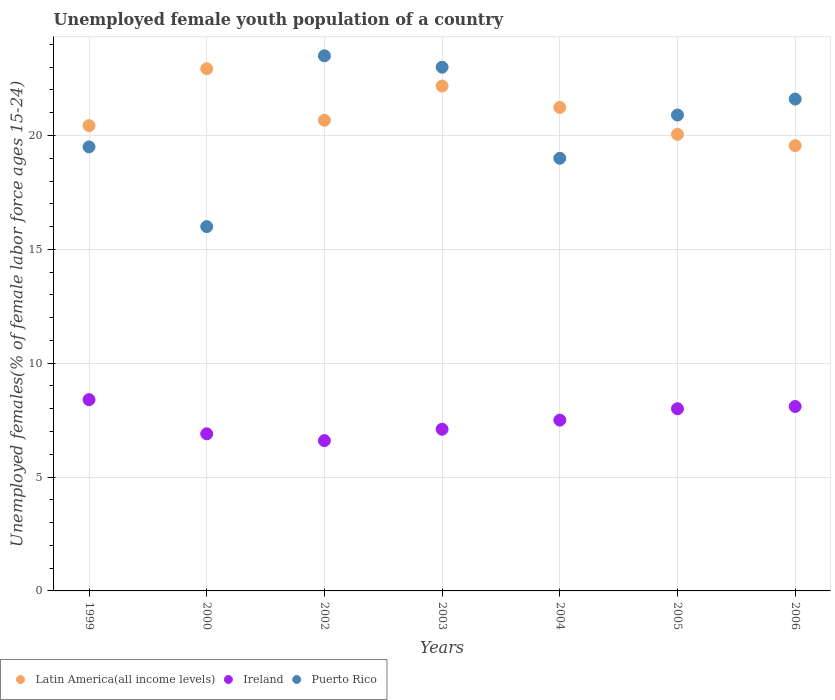What is the percentage of unemployed female youth population in Ireland in 2006?
Your answer should be very brief. 8.1. Across all years, what is the maximum percentage of unemployed female youth population in Puerto Rico?
Keep it short and to the point. 23.5. Across all years, what is the minimum percentage of unemployed female youth population in Puerto Rico?
Offer a terse response. 16. In which year was the percentage of unemployed female youth population in Puerto Rico minimum?
Keep it short and to the point. 2000. What is the total percentage of unemployed female youth population in Latin America(all income levels) in the graph?
Your answer should be very brief. 147.05. What is the difference between the percentage of unemployed female youth population in Ireland in 2002 and that in 2006?
Give a very brief answer. -1.5. What is the difference between the percentage of unemployed female youth population in Puerto Rico in 2002 and the percentage of unemployed female youth population in Latin America(all income levels) in 2005?
Make the answer very short. 3.45. What is the average percentage of unemployed female youth population in Latin America(all income levels) per year?
Offer a very short reply. 21.01. In the year 2005, what is the difference between the percentage of unemployed female youth population in Latin America(all income levels) and percentage of unemployed female youth population in Puerto Rico?
Keep it short and to the point. -0.85. In how many years, is the percentage of unemployed female youth population in Puerto Rico greater than 6 %?
Your response must be concise. 7. What is the ratio of the percentage of unemployed female youth population in Latin America(all income levels) in 2004 to that in 2005?
Make the answer very short. 1.06. What is the difference between the highest and the second highest percentage of unemployed female youth population in Latin America(all income levels)?
Provide a short and direct response. 0.76. What is the difference between the highest and the lowest percentage of unemployed female youth population in Latin America(all income levels)?
Your response must be concise. 3.38. Is the sum of the percentage of unemployed female youth population in Latin America(all income levels) in 2000 and 2004 greater than the maximum percentage of unemployed female youth population in Puerto Rico across all years?
Give a very brief answer. Yes. Is it the case that in every year, the sum of the percentage of unemployed female youth population in Latin America(all income levels) and percentage of unemployed female youth population in Ireland  is greater than the percentage of unemployed female youth population in Puerto Rico?
Provide a short and direct response. Yes. How many dotlines are there?
Your answer should be very brief. 3. What is the difference between two consecutive major ticks on the Y-axis?
Make the answer very short. 5. Does the graph contain any zero values?
Your response must be concise. No. Does the graph contain grids?
Your answer should be very brief. Yes. How many legend labels are there?
Your answer should be very brief. 3. What is the title of the graph?
Your answer should be compact. Unemployed female youth population of a country. Does "Burundi" appear as one of the legend labels in the graph?
Give a very brief answer. No. What is the label or title of the Y-axis?
Your answer should be compact. Unemployed females(% of female labor force ages 15-24). What is the Unemployed females(% of female labor force ages 15-24) in Latin America(all income levels) in 1999?
Provide a succinct answer. 20.43. What is the Unemployed females(% of female labor force ages 15-24) of Ireland in 1999?
Offer a very short reply. 8.4. What is the Unemployed females(% of female labor force ages 15-24) in Latin America(all income levels) in 2000?
Offer a very short reply. 22.93. What is the Unemployed females(% of female labor force ages 15-24) in Ireland in 2000?
Keep it short and to the point. 6.9. What is the Unemployed females(% of female labor force ages 15-24) of Puerto Rico in 2000?
Offer a terse response. 16. What is the Unemployed females(% of female labor force ages 15-24) of Latin America(all income levels) in 2002?
Provide a succinct answer. 20.67. What is the Unemployed females(% of female labor force ages 15-24) in Ireland in 2002?
Your response must be concise. 6.6. What is the Unemployed females(% of female labor force ages 15-24) in Latin America(all income levels) in 2003?
Give a very brief answer. 22.17. What is the Unemployed females(% of female labor force ages 15-24) in Ireland in 2003?
Offer a very short reply. 7.1. What is the Unemployed females(% of female labor force ages 15-24) of Latin America(all income levels) in 2004?
Your answer should be compact. 21.23. What is the Unemployed females(% of female labor force ages 15-24) in Latin America(all income levels) in 2005?
Ensure brevity in your answer.  20.05. What is the Unemployed females(% of female labor force ages 15-24) in Ireland in 2005?
Make the answer very short. 8. What is the Unemployed females(% of female labor force ages 15-24) in Puerto Rico in 2005?
Ensure brevity in your answer.  20.9. What is the Unemployed females(% of female labor force ages 15-24) in Latin America(all income levels) in 2006?
Make the answer very short. 19.56. What is the Unemployed females(% of female labor force ages 15-24) in Ireland in 2006?
Give a very brief answer. 8.1. What is the Unemployed females(% of female labor force ages 15-24) in Puerto Rico in 2006?
Offer a very short reply. 21.6. Across all years, what is the maximum Unemployed females(% of female labor force ages 15-24) in Latin America(all income levels)?
Offer a very short reply. 22.93. Across all years, what is the maximum Unemployed females(% of female labor force ages 15-24) of Ireland?
Offer a very short reply. 8.4. Across all years, what is the maximum Unemployed females(% of female labor force ages 15-24) of Puerto Rico?
Give a very brief answer. 23.5. Across all years, what is the minimum Unemployed females(% of female labor force ages 15-24) of Latin America(all income levels)?
Offer a very short reply. 19.56. Across all years, what is the minimum Unemployed females(% of female labor force ages 15-24) of Ireland?
Your response must be concise. 6.6. What is the total Unemployed females(% of female labor force ages 15-24) in Latin America(all income levels) in the graph?
Your answer should be compact. 147.05. What is the total Unemployed females(% of female labor force ages 15-24) in Ireland in the graph?
Ensure brevity in your answer.  52.6. What is the total Unemployed females(% of female labor force ages 15-24) of Puerto Rico in the graph?
Offer a very short reply. 143.5. What is the difference between the Unemployed females(% of female labor force ages 15-24) of Latin America(all income levels) in 1999 and that in 2000?
Offer a very short reply. -2.5. What is the difference between the Unemployed females(% of female labor force ages 15-24) in Latin America(all income levels) in 1999 and that in 2002?
Your response must be concise. -0.24. What is the difference between the Unemployed females(% of female labor force ages 15-24) of Puerto Rico in 1999 and that in 2002?
Provide a short and direct response. -4. What is the difference between the Unemployed females(% of female labor force ages 15-24) in Latin America(all income levels) in 1999 and that in 2003?
Your response must be concise. -1.74. What is the difference between the Unemployed females(% of female labor force ages 15-24) of Latin America(all income levels) in 1999 and that in 2004?
Make the answer very short. -0.8. What is the difference between the Unemployed females(% of female labor force ages 15-24) of Latin America(all income levels) in 1999 and that in 2005?
Your answer should be very brief. 0.38. What is the difference between the Unemployed females(% of female labor force ages 15-24) of Latin America(all income levels) in 1999 and that in 2006?
Keep it short and to the point. 0.88. What is the difference between the Unemployed females(% of female labor force ages 15-24) of Ireland in 1999 and that in 2006?
Keep it short and to the point. 0.3. What is the difference between the Unemployed females(% of female labor force ages 15-24) of Puerto Rico in 1999 and that in 2006?
Give a very brief answer. -2.1. What is the difference between the Unemployed females(% of female labor force ages 15-24) of Latin America(all income levels) in 2000 and that in 2002?
Provide a short and direct response. 2.26. What is the difference between the Unemployed females(% of female labor force ages 15-24) of Puerto Rico in 2000 and that in 2002?
Provide a short and direct response. -7.5. What is the difference between the Unemployed females(% of female labor force ages 15-24) of Latin America(all income levels) in 2000 and that in 2003?
Make the answer very short. 0.76. What is the difference between the Unemployed females(% of female labor force ages 15-24) of Ireland in 2000 and that in 2003?
Give a very brief answer. -0.2. What is the difference between the Unemployed females(% of female labor force ages 15-24) in Puerto Rico in 2000 and that in 2003?
Keep it short and to the point. -7. What is the difference between the Unemployed females(% of female labor force ages 15-24) of Latin America(all income levels) in 2000 and that in 2004?
Give a very brief answer. 1.7. What is the difference between the Unemployed females(% of female labor force ages 15-24) of Ireland in 2000 and that in 2004?
Your answer should be compact. -0.6. What is the difference between the Unemployed females(% of female labor force ages 15-24) in Latin America(all income levels) in 2000 and that in 2005?
Provide a short and direct response. 2.88. What is the difference between the Unemployed females(% of female labor force ages 15-24) in Puerto Rico in 2000 and that in 2005?
Ensure brevity in your answer.  -4.9. What is the difference between the Unemployed females(% of female labor force ages 15-24) in Latin America(all income levels) in 2000 and that in 2006?
Ensure brevity in your answer.  3.38. What is the difference between the Unemployed females(% of female labor force ages 15-24) in Ireland in 2000 and that in 2006?
Your answer should be compact. -1.2. What is the difference between the Unemployed females(% of female labor force ages 15-24) of Puerto Rico in 2000 and that in 2006?
Make the answer very short. -5.6. What is the difference between the Unemployed females(% of female labor force ages 15-24) in Latin America(all income levels) in 2002 and that in 2003?
Provide a short and direct response. -1.5. What is the difference between the Unemployed females(% of female labor force ages 15-24) of Ireland in 2002 and that in 2003?
Ensure brevity in your answer.  -0.5. What is the difference between the Unemployed females(% of female labor force ages 15-24) in Latin America(all income levels) in 2002 and that in 2004?
Your answer should be very brief. -0.56. What is the difference between the Unemployed females(% of female labor force ages 15-24) of Ireland in 2002 and that in 2004?
Your answer should be very brief. -0.9. What is the difference between the Unemployed females(% of female labor force ages 15-24) of Latin America(all income levels) in 2002 and that in 2005?
Your response must be concise. 0.62. What is the difference between the Unemployed females(% of female labor force ages 15-24) in Ireland in 2002 and that in 2005?
Ensure brevity in your answer.  -1.4. What is the difference between the Unemployed females(% of female labor force ages 15-24) of Puerto Rico in 2002 and that in 2005?
Provide a short and direct response. 2.6. What is the difference between the Unemployed females(% of female labor force ages 15-24) in Latin America(all income levels) in 2002 and that in 2006?
Your answer should be compact. 1.12. What is the difference between the Unemployed females(% of female labor force ages 15-24) in Latin America(all income levels) in 2003 and that in 2004?
Offer a very short reply. 0.94. What is the difference between the Unemployed females(% of female labor force ages 15-24) of Ireland in 2003 and that in 2004?
Your answer should be compact. -0.4. What is the difference between the Unemployed females(% of female labor force ages 15-24) in Puerto Rico in 2003 and that in 2004?
Give a very brief answer. 4. What is the difference between the Unemployed females(% of female labor force ages 15-24) in Latin America(all income levels) in 2003 and that in 2005?
Make the answer very short. 2.12. What is the difference between the Unemployed females(% of female labor force ages 15-24) of Ireland in 2003 and that in 2005?
Keep it short and to the point. -0.9. What is the difference between the Unemployed females(% of female labor force ages 15-24) in Latin America(all income levels) in 2003 and that in 2006?
Offer a terse response. 2.62. What is the difference between the Unemployed females(% of female labor force ages 15-24) in Ireland in 2003 and that in 2006?
Your response must be concise. -1. What is the difference between the Unemployed females(% of female labor force ages 15-24) of Puerto Rico in 2003 and that in 2006?
Provide a succinct answer. 1.4. What is the difference between the Unemployed females(% of female labor force ages 15-24) of Latin America(all income levels) in 2004 and that in 2005?
Give a very brief answer. 1.18. What is the difference between the Unemployed females(% of female labor force ages 15-24) of Latin America(all income levels) in 2004 and that in 2006?
Your answer should be very brief. 1.68. What is the difference between the Unemployed females(% of female labor force ages 15-24) of Ireland in 2004 and that in 2006?
Offer a very short reply. -0.6. What is the difference between the Unemployed females(% of female labor force ages 15-24) of Puerto Rico in 2004 and that in 2006?
Offer a very short reply. -2.6. What is the difference between the Unemployed females(% of female labor force ages 15-24) of Latin America(all income levels) in 2005 and that in 2006?
Your response must be concise. 0.5. What is the difference between the Unemployed females(% of female labor force ages 15-24) in Ireland in 2005 and that in 2006?
Your answer should be compact. -0.1. What is the difference between the Unemployed females(% of female labor force ages 15-24) in Puerto Rico in 2005 and that in 2006?
Your answer should be compact. -0.7. What is the difference between the Unemployed females(% of female labor force ages 15-24) in Latin America(all income levels) in 1999 and the Unemployed females(% of female labor force ages 15-24) in Ireland in 2000?
Your answer should be very brief. 13.53. What is the difference between the Unemployed females(% of female labor force ages 15-24) of Latin America(all income levels) in 1999 and the Unemployed females(% of female labor force ages 15-24) of Puerto Rico in 2000?
Make the answer very short. 4.43. What is the difference between the Unemployed females(% of female labor force ages 15-24) in Ireland in 1999 and the Unemployed females(% of female labor force ages 15-24) in Puerto Rico in 2000?
Make the answer very short. -7.6. What is the difference between the Unemployed females(% of female labor force ages 15-24) of Latin America(all income levels) in 1999 and the Unemployed females(% of female labor force ages 15-24) of Ireland in 2002?
Ensure brevity in your answer.  13.83. What is the difference between the Unemployed females(% of female labor force ages 15-24) in Latin America(all income levels) in 1999 and the Unemployed females(% of female labor force ages 15-24) in Puerto Rico in 2002?
Your answer should be very brief. -3.07. What is the difference between the Unemployed females(% of female labor force ages 15-24) of Ireland in 1999 and the Unemployed females(% of female labor force ages 15-24) of Puerto Rico in 2002?
Ensure brevity in your answer.  -15.1. What is the difference between the Unemployed females(% of female labor force ages 15-24) of Latin America(all income levels) in 1999 and the Unemployed females(% of female labor force ages 15-24) of Ireland in 2003?
Give a very brief answer. 13.33. What is the difference between the Unemployed females(% of female labor force ages 15-24) in Latin America(all income levels) in 1999 and the Unemployed females(% of female labor force ages 15-24) in Puerto Rico in 2003?
Your response must be concise. -2.57. What is the difference between the Unemployed females(% of female labor force ages 15-24) of Ireland in 1999 and the Unemployed females(% of female labor force ages 15-24) of Puerto Rico in 2003?
Offer a very short reply. -14.6. What is the difference between the Unemployed females(% of female labor force ages 15-24) of Latin America(all income levels) in 1999 and the Unemployed females(% of female labor force ages 15-24) of Ireland in 2004?
Keep it short and to the point. 12.93. What is the difference between the Unemployed females(% of female labor force ages 15-24) in Latin America(all income levels) in 1999 and the Unemployed females(% of female labor force ages 15-24) in Puerto Rico in 2004?
Provide a succinct answer. 1.43. What is the difference between the Unemployed females(% of female labor force ages 15-24) in Latin America(all income levels) in 1999 and the Unemployed females(% of female labor force ages 15-24) in Ireland in 2005?
Keep it short and to the point. 12.43. What is the difference between the Unemployed females(% of female labor force ages 15-24) of Latin America(all income levels) in 1999 and the Unemployed females(% of female labor force ages 15-24) of Puerto Rico in 2005?
Provide a succinct answer. -0.47. What is the difference between the Unemployed females(% of female labor force ages 15-24) in Ireland in 1999 and the Unemployed females(% of female labor force ages 15-24) in Puerto Rico in 2005?
Your answer should be compact. -12.5. What is the difference between the Unemployed females(% of female labor force ages 15-24) in Latin America(all income levels) in 1999 and the Unemployed females(% of female labor force ages 15-24) in Ireland in 2006?
Ensure brevity in your answer.  12.33. What is the difference between the Unemployed females(% of female labor force ages 15-24) of Latin America(all income levels) in 1999 and the Unemployed females(% of female labor force ages 15-24) of Puerto Rico in 2006?
Your answer should be very brief. -1.17. What is the difference between the Unemployed females(% of female labor force ages 15-24) of Ireland in 1999 and the Unemployed females(% of female labor force ages 15-24) of Puerto Rico in 2006?
Make the answer very short. -13.2. What is the difference between the Unemployed females(% of female labor force ages 15-24) of Latin America(all income levels) in 2000 and the Unemployed females(% of female labor force ages 15-24) of Ireland in 2002?
Offer a terse response. 16.33. What is the difference between the Unemployed females(% of female labor force ages 15-24) in Latin America(all income levels) in 2000 and the Unemployed females(% of female labor force ages 15-24) in Puerto Rico in 2002?
Offer a terse response. -0.57. What is the difference between the Unemployed females(% of female labor force ages 15-24) of Ireland in 2000 and the Unemployed females(% of female labor force ages 15-24) of Puerto Rico in 2002?
Provide a short and direct response. -16.6. What is the difference between the Unemployed females(% of female labor force ages 15-24) in Latin America(all income levels) in 2000 and the Unemployed females(% of female labor force ages 15-24) in Ireland in 2003?
Offer a terse response. 15.83. What is the difference between the Unemployed females(% of female labor force ages 15-24) of Latin America(all income levels) in 2000 and the Unemployed females(% of female labor force ages 15-24) of Puerto Rico in 2003?
Offer a terse response. -0.07. What is the difference between the Unemployed females(% of female labor force ages 15-24) of Ireland in 2000 and the Unemployed females(% of female labor force ages 15-24) of Puerto Rico in 2003?
Offer a very short reply. -16.1. What is the difference between the Unemployed females(% of female labor force ages 15-24) of Latin America(all income levels) in 2000 and the Unemployed females(% of female labor force ages 15-24) of Ireland in 2004?
Make the answer very short. 15.43. What is the difference between the Unemployed females(% of female labor force ages 15-24) in Latin America(all income levels) in 2000 and the Unemployed females(% of female labor force ages 15-24) in Puerto Rico in 2004?
Your response must be concise. 3.93. What is the difference between the Unemployed females(% of female labor force ages 15-24) of Ireland in 2000 and the Unemployed females(% of female labor force ages 15-24) of Puerto Rico in 2004?
Keep it short and to the point. -12.1. What is the difference between the Unemployed females(% of female labor force ages 15-24) of Latin America(all income levels) in 2000 and the Unemployed females(% of female labor force ages 15-24) of Ireland in 2005?
Your response must be concise. 14.93. What is the difference between the Unemployed females(% of female labor force ages 15-24) of Latin America(all income levels) in 2000 and the Unemployed females(% of female labor force ages 15-24) of Puerto Rico in 2005?
Give a very brief answer. 2.03. What is the difference between the Unemployed females(% of female labor force ages 15-24) of Latin America(all income levels) in 2000 and the Unemployed females(% of female labor force ages 15-24) of Ireland in 2006?
Offer a terse response. 14.83. What is the difference between the Unemployed females(% of female labor force ages 15-24) in Latin America(all income levels) in 2000 and the Unemployed females(% of female labor force ages 15-24) in Puerto Rico in 2006?
Provide a succinct answer. 1.33. What is the difference between the Unemployed females(% of female labor force ages 15-24) in Ireland in 2000 and the Unemployed females(% of female labor force ages 15-24) in Puerto Rico in 2006?
Ensure brevity in your answer.  -14.7. What is the difference between the Unemployed females(% of female labor force ages 15-24) in Latin America(all income levels) in 2002 and the Unemployed females(% of female labor force ages 15-24) in Ireland in 2003?
Your answer should be very brief. 13.57. What is the difference between the Unemployed females(% of female labor force ages 15-24) in Latin America(all income levels) in 2002 and the Unemployed females(% of female labor force ages 15-24) in Puerto Rico in 2003?
Keep it short and to the point. -2.33. What is the difference between the Unemployed females(% of female labor force ages 15-24) of Ireland in 2002 and the Unemployed females(% of female labor force ages 15-24) of Puerto Rico in 2003?
Offer a very short reply. -16.4. What is the difference between the Unemployed females(% of female labor force ages 15-24) of Latin America(all income levels) in 2002 and the Unemployed females(% of female labor force ages 15-24) of Ireland in 2004?
Offer a terse response. 13.17. What is the difference between the Unemployed females(% of female labor force ages 15-24) in Latin America(all income levels) in 2002 and the Unemployed females(% of female labor force ages 15-24) in Puerto Rico in 2004?
Provide a short and direct response. 1.67. What is the difference between the Unemployed females(% of female labor force ages 15-24) of Ireland in 2002 and the Unemployed females(% of female labor force ages 15-24) of Puerto Rico in 2004?
Your response must be concise. -12.4. What is the difference between the Unemployed females(% of female labor force ages 15-24) of Latin America(all income levels) in 2002 and the Unemployed females(% of female labor force ages 15-24) of Ireland in 2005?
Make the answer very short. 12.67. What is the difference between the Unemployed females(% of female labor force ages 15-24) of Latin America(all income levels) in 2002 and the Unemployed females(% of female labor force ages 15-24) of Puerto Rico in 2005?
Give a very brief answer. -0.23. What is the difference between the Unemployed females(% of female labor force ages 15-24) of Ireland in 2002 and the Unemployed females(% of female labor force ages 15-24) of Puerto Rico in 2005?
Give a very brief answer. -14.3. What is the difference between the Unemployed females(% of female labor force ages 15-24) of Latin America(all income levels) in 2002 and the Unemployed females(% of female labor force ages 15-24) of Ireland in 2006?
Offer a terse response. 12.57. What is the difference between the Unemployed females(% of female labor force ages 15-24) in Latin America(all income levels) in 2002 and the Unemployed females(% of female labor force ages 15-24) in Puerto Rico in 2006?
Your response must be concise. -0.93. What is the difference between the Unemployed females(% of female labor force ages 15-24) in Ireland in 2002 and the Unemployed females(% of female labor force ages 15-24) in Puerto Rico in 2006?
Offer a terse response. -15. What is the difference between the Unemployed females(% of female labor force ages 15-24) in Latin America(all income levels) in 2003 and the Unemployed females(% of female labor force ages 15-24) in Ireland in 2004?
Your response must be concise. 14.67. What is the difference between the Unemployed females(% of female labor force ages 15-24) in Latin America(all income levels) in 2003 and the Unemployed females(% of female labor force ages 15-24) in Puerto Rico in 2004?
Provide a succinct answer. 3.17. What is the difference between the Unemployed females(% of female labor force ages 15-24) in Ireland in 2003 and the Unemployed females(% of female labor force ages 15-24) in Puerto Rico in 2004?
Your answer should be compact. -11.9. What is the difference between the Unemployed females(% of female labor force ages 15-24) in Latin America(all income levels) in 2003 and the Unemployed females(% of female labor force ages 15-24) in Ireland in 2005?
Provide a short and direct response. 14.17. What is the difference between the Unemployed females(% of female labor force ages 15-24) in Latin America(all income levels) in 2003 and the Unemployed females(% of female labor force ages 15-24) in Puerto Rico in 2005?
Your answer should be compact. 1.27. What is the difference between the Unemployed females(% of female labor force ages 15-24) in Latin America(all income levels) in 2003 and the Unemployed females(% of female labor force ages 15-24) in Ireland in 2006?
Offer a very short reply. 14.07. What is the difference between the Unemployed females(% of female labor force ages 15-24) in Latin America(all income levels) in 2003 and the Unemployed females(% of female labor force ages 15-24) in Puerto Rico in 2006?
Ensure brevity in your answer.  0.57. What is the difference between the Unemployed females(% of female labor force ages 15-24) of Ireland in 2003 and the Unemployed females(% of female labor force ages 15-24) of Puerto Rico in 2006?
Make the answer very short. -14.5. What is the difference between the Unemployed females(% of female labor force ages 15-24) of Latin America(all income levels) in 2004 and the Unemployed females(% of female labor force ages 15-24) of Ireland in 2005?
Your answer should be very brief. 13.23. What is the difference between the Unemployed females(% of female labor force ages 15-24) of Latin America(all income levels) in 2004 and the Unemployed females(% of female labor force ages 15-24) of Puerto Rico in 2005?
Ensure brevity in your answer.  0.33. What is the difference between the Unemployed females(% of female labor force ages 15-24) of Latin America(all income levels) in 2004 and the Unemployed females(% of female labor force ages 15-24) of Ireland in 2006?
Keep it short and to the point. 13.13. What is the difference between the Unemployed females(% of female labor force ages 15-24) of Latin America(all income levels) in 2004 and the Unemployed females(% of female labor force ages 15-24) of Puerto Rico in 2006?
Give a very brief answer. -0.37. What is the difference between the Unemployed females(% of female labor force ages 15-24) of Ireland in 2004 and the Unemployed females(% of female labor force ages 15-24) of Puerto Rico in 2006?
Make the answer very short. -14.1. What is the difference between the Unemployed females(% of female labor force ages 15-24) of Latin America(all income levels) in 2005 and the Unemployed females(% of female labor force ages 15-24) of Ireland in 2006?
Make the answer very short. 11.95. What is the difference between the Unemployed females(% of female labor force ages 15-24) in Latin America(all income levels) in 2005 and the Unemployed females(% of female labor force ages 15-24) in Puerto Rico in 2006?
Your answer should be compact. -1.55. What is the difference between the Unemployed females(% of female labor force ages 15-24) in Ireland in 2005 and the Unemployed females(% of female labor force ages 15-24) in Puerto Rico in 2006?
Your response must be concise. -13.6. What is the average Unemployed females(% of female labor force ages 15-24) in Latin America(all income levels) per year?
Give a very brief answer. 21.01. What is the average Unemployed females(% of female labor force ages 15-24) in Ireland per year?
Ensure brevity in your answer.  7.51. What is the average Unemployed females(% of female labor force ages 15-24) in Puerto Rico per year?
Provide a short and direct response. 20.5. In the year 1999, what is the difference between the Unemployed females(% of female labor force ages 15-24) in Latin America(all income levels) and Unemployed females(% of female labor force ages 15-24) in Ireland?
Your response must be concise. 12.03. In the year 1999, what is the difference between the Unemployed females(% of female labor force ages 15-24) of Latin America(all income levels) and Unemployed females(% of female labor force ages 15-24) of Puerto Rico?
Provide a succinct answer. 0.93. In the year 1999, what is the difference between the Unemployed females(% of female labor force ages 15-24) in Ireland and Unemployed females(% of female labor force ages 15-24) in Puerto Rico?
Offer a very short reply. -11.1. In the year 2000, what is the difference between the Unemployed females(% of female labor force ages 15-24) of Latin America(all income levels) and Unemployed females(% of female labor force ages 15-24) of Ireland?
Offer a very short reply. 16.03. In the year 2000, what is the difference between the Unemployed females(% of female labor force ages 15-24) of Latin America(all income levels) and Unemployed females(% of female labor force ages 15-24) of Puerto Rico?
Offer a very short reply. 6.93. In the year 2000, what is the difference between the Unemployed females(% of female labor force ages 15-24) of Ireland and Unemployed females(% of female labor force ages 15-24) of Puerto Rico?
Keep it short and to the point. -9.1. In the year 2002, what is the difference between the Unemployed females(% of female labor force ages 15-24) in Latin America(all income levels) and Unemployed females(% of female labor force ages 15-24) in Ireland?
Your response must be concise. 14.07. In the year 2002, what is the difference between the Unemployed females(% of female labor force ages 15-24) in Latin America(all income levels) and Unemployed females(% of female labor force ages 15-24) in Puerto Rico?
Offer a very short reply. -2.83. In the year 2002, what is the difference between the Unemployed females(% of female labor force ages 15-24) in Ireland and Unemployed females(% of female labor force ages 15-24) in Puerto Rico?
Give a very brief answer. -16.9. In the year 2003, what is the difference between the Unemployed females(% of female labor force ages 15-24) of Latin America(all income levels) and Unemployed females(% of female labor force ages 15-24) of Ireland?
Provide a succinct answer. 15.07. In the year 2003, what is the difference between the Unemployed females(% of female labor force ages 15-24) of Latin America(all income levels) and Unemployed females(% of female labor force ages 15-24) of Puerto Rico?
Your response must be concise. -0.83. In the year 2003, what is the difference between the Unemployed females(% of female labor force ages 15-24) of Ireland and Unemployed females(% of female labor force ages 15-24) of Puerto Rico?
Offer a very short reply. -15.9. In the year 2004, what is the difference between the Unemployed females(% of female labor force ages 15-24) in Latin America(all income levels) and Unemployed females(% of female labor force ages 15-24) in Ireland?
Your answer should be very brief. 13.73. In the year 2004, what is the difference between the Unemployed females(% of female labor force ages 15-24) in Latin America(all income levels) and Unemployed females(% of female labor force ages 15-24) in Puerto Rico?
Provide a succinct answer. 2.23. In the year 2005, what is the difference between the Unemployed females(% of female labor force ages 15-24) of Latin America(all income levels) and Unemployed females(% of female labor force ages 15-24) of Ireland?
Your response must be concise. 12.05. In the year 2005, what is the difference between the Unemployed females(% of female labor force ages 15-24) in Latin America(all income levels) and Unemployed females(% of female labor force ages 15-24) in Puerto Rico?
Ensure brevity in your answer.  -0.85. In the year 2005, what is the difference between the Unemployed females(% of female labor force ages 15-24) in Ireland and Unemployed females(% of female labor force ages 15-24) in Puerto Rico?
Provide a short and direct response. -12.9. In the year 2006, what is the difference between the Unemployed females(% of female labor force ages 15-24) in Latin America(all income levels) and Unemployed females(% of female labor force ages 15-24) in Ireland?
Give a very brief answer. 11.46. In the year 2006, what is the difference between the Unemployed females(% of female labor force ages 15-24) in Latin America(all income levels) and Unemployed females(% of female labor force ages 15-24) in Puerto Rico?
Provide a succinct answer. -2.04. What is the ratio of the Unemployed females(% of female labor force ages 15-24) of Latin America(all income levels) in 1999 to that in 2000?
Provide a succinct answer. 0.89. What is the ratio of the Unemployed females(% of female labor force ages 15-24) of Ireland in 1999 to that in 2000?
Offer a very short reply. 1.22. What is the ratio of the Unemployed females(% of female labor force ages 15-24) in Puerto Rico in 1999 to that in 2000?
Give a very brief answer. 1.22. What is the ratio of the Unemployed females(% of female labor force ages 15-24) in Latin America(all income levels) in 1999 to that in 2002?
Provide a succinct answer. 0.99. What is the ratio of the Unemployed females(% of female labor force ages 15-24) in Ireland in 1999 to that in 2002?
Ensure brevity in your answer.  1.27. What is the ratio of the Unemployed females(% of female labor force ages 15-24) of Puerto Rico in 1999 to that in 2002?
Offer a terse response. 0.83. What is the ratio of the Unemployed females(% of female labor force ages 15-24) in Latin America(all income levels) in 1999 to that in 2003?
Your answer should be very brief. 0.92. What is the ratio of the Unemployed females(% of female labor force ages 15-24) in Ireland in 1999 to that in 2003?
Make the answer very short. 1.18. What is the ratio of the Unemployed females(% of female labor force ages 15-24) in Puerto Rico in 1999 to that in 2003?
Your answer should be compact. 0.85. What is the ratio of the Unemployed females(% of female labor force ages 15-24) of Latin America(all income levels) in 1999 to that in 2004?
Your answer should be compact. 0.96. What is the ratio of the Unemployed females(% of female labor force ages 15-24) of Ireland in 1999 to that in 2004?
Your answer should be very brief. 1.12. What is the ratio of the Unemployed females(% of female labor force ages 15-24) in Puerto Rico in 1999 to that in 2004?
Provide a short and direct response. 1.03. What is the ratio of the Unemployed females(% of female labor force ages 15-24) of Latin America(all income levels) in 1999 to that in 2005?
Make the answer very short. 1.02. What is the ratio of the Unemployed females(% of female labor force ages 15-24) of Puerto Rico in 1999 to that in 2005?
Give a very brief answer. 0.93. What is the ratio of the Unemployed females(% of female labor force ages 15-24) of Latin America(all income levels) in 1999 to that in 2006?
Your answer should be compact. 1.04. What is the ratio of the Unemployed females(% of female labor force ages 15-24) in Puerto Rico in 1999 to that in 2006?
Give a very brief answer. 0.9. What is the ratio of the Unemployed females(% of female labor force ages 15-24) in Latin America(all income levels) in 2000 to that in 2002?
Your answer should be compact. 1.11. What is the ratio of the Unemployed females(% of female labor force ages 15-24) of Ireland in 2000 to that in 2002?
Offer a very short reply. 1.05. What is the ratio of the Unemployed females(% of female labor force ages 15-24) of Puerto Rico in 2000 to that in 2002?
Provide a short and direct response. 0.68. What is the ratio of the Unemployed females(% of female labor force ages 15-24) in Latin America(all income levels) in 2000 to that in 2003?
Offer a terse response. 1.03. What is the ratio of the Unemployed females(% of female labor force ages 15-24) of Ireland in 2000 to that in 2003?
Provide a succinct answer. 0.97. What is the ratio of the Unemployed females(% of female labor force ages 15-24) of Puerto Rico in 2000 to that in 2003?
Your response must be concise. 0.7. What is the ratio of the Unemployed females(% of female labor force ages 15-24) in Latin America(all income levels) in 2000 to that in 2004?
Provide a short and direct response. 1.08. What is the ratio of the Unemployed females(% of female labor force ages 15-24) in Ireland in 2000 to that in 2004?
Your answer should be compact. 0.92. What is the ratio of the Unemployed females(% of female labor force ages 15-24) in Puerto Rico in 2000 to that in 2004?
Make the answer very short. 0.84. What is the ratio of the Unemployed females(% of female labor force ages 15-24) of Latin America(all income levels) in 2000 to that in 2005?
Your response must be concise. 1.14. What is the ratio of the Unemployed females(% of female labor force ages 15-24) in Ireland in 2000 to that in 2005?
Your response must be concise. 0.86. What is the ratio of the Unemployed females(% of female labor force ages 15-24) in Puerto Rico in 2000 to that in 2005?
Your response must be concise. 0.77. What is the ratio of the Unemployed females(% of female labor force ages 15-24) in Latin America(all income levels) in 2000 to that in 2006?
Your answer should be very brief. 1.17. What is the ratio of the Unemployed females(% of female labor force ages 15-24) of Ireland in 2000 to that in 2006?
Provide a short and direct response. 0.85. What is the ratio of the Unemployed females(% of female labor force ages 15-24) of Puerto Rico in 2000 to that in 2006?
Ensure brevity in your answer.  0.74. What is the ratio of the Unemployed females(% of female labor force ages 15-24) of Latin America(all income levels) in 2002 to that in 2003?
Offer a very short reply. 0.93. What is the ratio of the Unemployed females(% of female labor force ages 15-24) of Ireland in 2002 to that in 2003?
Ensure brevity in your answer.  0.93. What is the ratio of the Unemployed females(% of female labor force ages 15-24) of Puerto Rico in 2002 to that in 2003?
Offer a very short reply. 1.02. What is the ratio of the Unemployed females(% of female labor force ages 15-24) of Latin America(all income levels) in 2002 to that in 2004?
Offer a terse response. 0.97. What is the ratio of the Unemployed females(% of female labor force ages 15-24) of Puerto Rico in 2002 to that in 2004?
Offer a terse response. 1.24. What is the ratio of the Unemployed females(% of female labor force ages 15-24) in Latin America(all income levels) in 2002 to that in 2005?
Your answer should be compact. 1.03. What is the ratio of the Unemployed females(% of female labor force ages 15-24) in Ireland in 2002 to that in 2005?
Give a very brief answer. 0.82. What is the ratio of the Unemployed females(% of female labor force ages 15-24) in Puerto Rico in 2002 to that in 2005?
Make the answer very short. 1.12. What is the ratio of the Unemployed females(% of female labor force ages 15-24) of Latin America(all income levels) in 2002 to that in 2006?
Your answer should be compact. 1.06. What is the ratio of the Unemployed females(% of female labor force ages 15-24) in Ireland in 2002 to that in 2006?
Offer a very short reply. 0.81. What is the ratio of the Unemployed females(% of female labor force ages 15-24) in Puerto Rico in 2002 to that in 2006?
Provide a succinct answer. 1.09. What is the ratio of the Unemployed females(% of female labor force ages 15-24) of Latin America(all income levels) in 2003 to that in 2004?
Make the answer very short. 1.04. What is the ratio of the Unemployed females(% of female labor force ages 15-24) in Ireland in 2003 to that in 2004?
Your response must be concise. 0.95. What is the ratio of the Unemployed females(% of female labor force ages 15-24) of Puerto Rico in 2003 to that in 2004?
Offer a very short reply. 1.21. What is the ratio of the Unemployed females(% of female labor force ages 15-24) of Latin America(all income levels) in 2003 to that in 2005?
Give a very brief answer. 1.11. What is the ratio of the Unemployed females(% of female labor force ages 15-24) in Ireland in 2003 to that in 2005?
Your answer should be very brief. 0.89. What is the ratio of the Unemployed females(% of female labor force ages 15-24) of Puerto Rico in 2003 to that in 2005?
Make the answer very short. 1.1. What is the ratio of the Unemployed females(% of female labor force ages 15-24) in Latin America(all income levels) in 2003 to that in 2006?
Give a very brief answer. 1.13. What is the ratio of the Unemployed females(% of female labor force ages 15-24) in Ireland in 2003 to that in 2006?
Your answer should be very brief. 0.88. What is the ratio of the Unemployed females(% of female labor force ages 15-24) of Puerto Rico in 2003 to that in 2006?
Your response must be concise. 1.06. What is the ratio of the Unemployed females(% of female labor force ages 15-24) of Latin America(all income levels) in 2004 to that in 2005?
Your answer should be very brief. 1.06. What is the ratio of the Unemployed females(% of female labor force ages 15-24) in Ireland in 2004 to that in 2005?
Provide a short and direct response. 0.94. What is the ratio of the Unemployed females(% of female labor force ages 15-24) of Latin America(all income levels) in 2004 to that in 2006?
Provide a short and direct response. 1.09. What is the ratio of the Unemployed females(% of female labor force ages 15-24) of Ireland in 2004 to that in 2006?
Offer a very short reply. 0.93. What is the ratio of the Unemployed females(% of female labor force ages 15-24) in Puerto Rico in 2004 to that in 2006?
Your response must be concise. 0.88. What is the ratio of the Unemployed females(% of female labor force ages 15-24) in Latin America(all income levels) in 2005 to that in 2006?
Your answer should be compact. 1.03. What is the ratio of the Unemployed females(% of female labor force ages 15-24) of Puerto Rico in 2005 to that in 2006?
Your response must be concise. 0.97. What is the difference between the highest and the second highest Unemployed females(% of female labor force ages 15-24) of Latin America(all income levels)?
Your response must be concise. 0.76. What is the difference between the highest and the second highest Unemployed females(% of female labor force ages 15-24) in Ireland?
Give a very brief answer. 0.3. What is the difference between the highest and the second highest Unemployed females(% of female labor force ages 15-24) of Puerto Rico?
Your answer should be compact. 0.5. What is the difference between the highest and the lowest Unemployed females(% of female labor force ages 15-24) in Latin America(all income levels)?
Keep it short and to the point. 3.38. What is the difference between the highest and the lowest Unemployed females(% of female labor force ages 15-24) in Ireland?
Your response must be concise. 1.8. What is the difference between the highest and the lowest Unemployed females(% of female labor force ages 15-24) of Puerto Rico?
Offer a terse response. 7.5. 